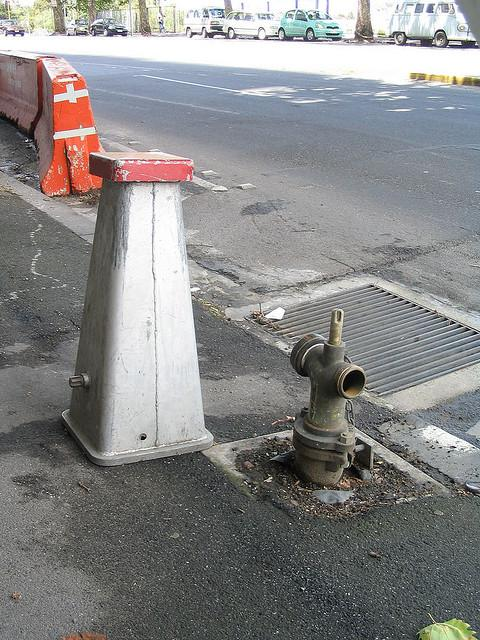What is on the floor? Please explain your reasoning. grate. There is a metal grate on the floor of the street near the pipe. 